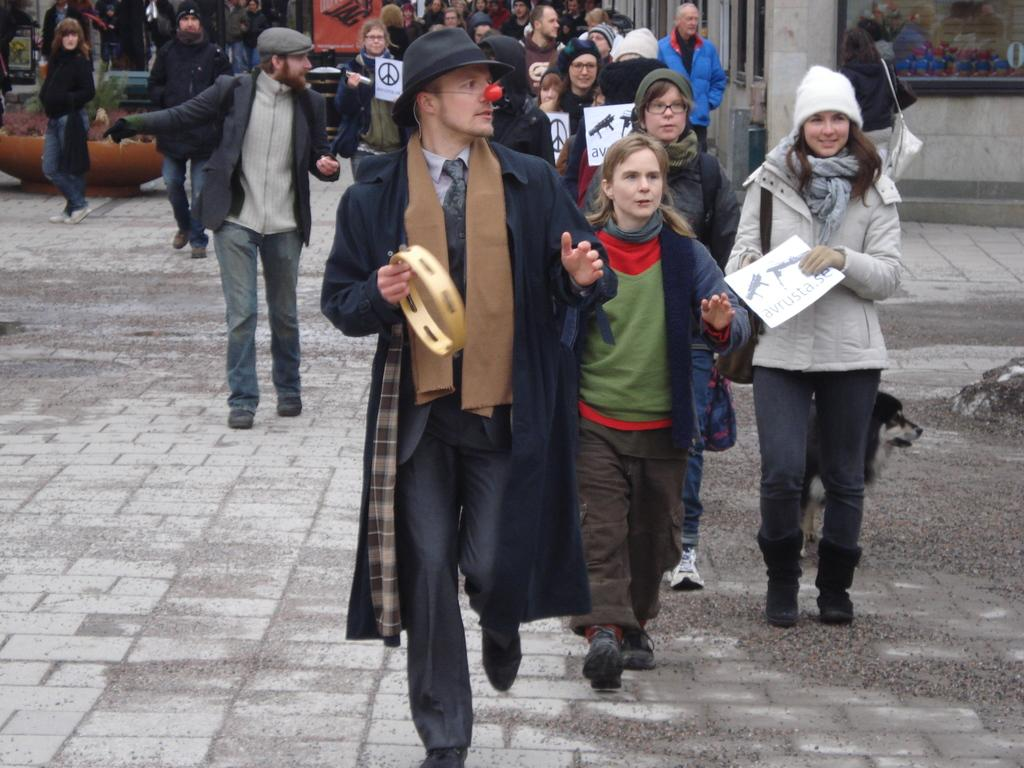How many persons are in the image? There are persons in the image. What type of clothing are the persons wearing? The persons are wearing sweaters and caps. What are the persons holding in their hands? The persons are holding boards in their hands. What can be seen in the background of the image? There are buildings in the background of the image. What type of tank can be seen in the image? There is no tank present in the image. What is the ground like in the image? The ground is not explicitly described in the image, but it is likely that there is some type of surface beneath the persons and buildings. 